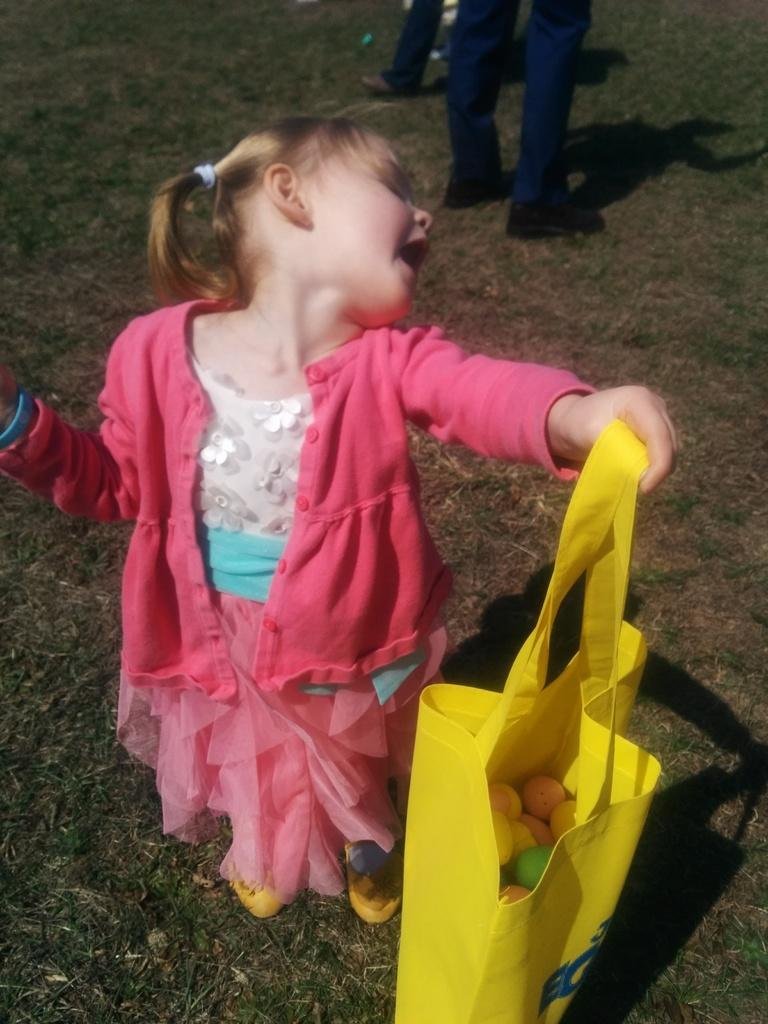Who is the main subject in the image? There is a girl in the image. What is the girl holding in the image? The girl is holding a bag. Can you describe the contents of the bag? There are objects inside the bag. What type of environment is visible in the image? There is a grassy land in the image. How many people are standing beside the girl? There are two persons standing beside the girl. What type of power source is visible in the image? There is no power source visible in the image. What type of meal is the girl eating in the image? The girl is not eating a meal in the image; she is holding a bag. 